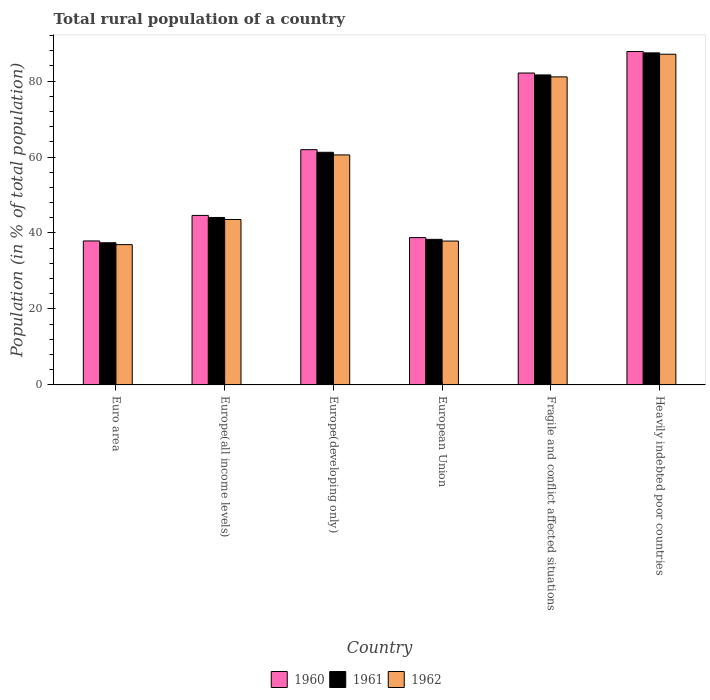How many different coloured bars are there?
Offer a very short reply. 3. Are the number of bars per tick equal to the number of legend labels?
Ensure brevity in your answer.  Yes. How many bars are there on the 2nd tick from the right?
Ensure brevity in your answer.  3. What is the label of the 6th group of bars from the left?
Offer a very short reply. Heavily indebted poor countries. In how many cases, is the number of bars for a given country not equal to the number of legend labels?
Your response must be concise. 0. What is the rural population in 1961 in Europe(developing only)?
Offer a terse response. 61.24. Across all countries, what is the maximum rural population in 1961?
Your response must be concise. 87.42. Across all countries, what is the minimum rural population in 1962?
Provide a short and direct response. 36.93. In which country was the rural population in 1961 maximum?
Make the answer very short. Heavily indebted poor countries. In which country was the rural population in 1961 minimum?
Your answer should be compact. Euro area. What is the total rural population in 1960 in the graph?
Offer a terse response. 353.12. What is the difference between the rural population in 1962 in Euro area and that in Heavily indebted poor countries?
Give a very brief answer. -50.13. What is the difference between the rural population in 1961 in European Union and the rural population in 1960 in Heavily indebted poor countries?
Ensure brevity in your answer.  -49.44. What is the average rural population in 1960 per country?
Your response must be concise. 58.85. What is the difference between the rural population of/in 1960 and rural population of/in 1961 in Euro area?
Your response must be concise. 0.48. What is the ratio of the rural population in 1961 in Fragile and conflict affected situations to that in Heavily indebted poor countries?
Make the answer very short. 0.93. Is the rural population in 1961 in Europe(all income levels) less than that in European Union?
Your response must be concise. No. Is the difference between the rural population in 1960 in Europe(all income levels) and Europe(developing only) greater than the difference between the rural population in 1961 in Europe(all income levels) and Europe(developing only)?
Offer a terse response. No. What is the difference between the highest and the second highest rural population in 1961?
Give a very brief answer. 20.37. What is the difference between the highest and the lowest rural population in 1960?
Your response must be concise. 49.86. In how many countries, is the rural population in 1962 greater than the average rural population in 1962 taken over all countries?
Keep it short and to the point. 3. Is the sum of the rural population in 1960 in Euro area and Fragile and conflict affected situations greater than the maximum rural population in 1961 across all countries?
Your answer should be very brief. Yes. What does the 3rd bar from the left in European Union represents?
Keep it short and to the point. 1962. What does the 2nd bar from the right in Heavily indebted poor countries represents?
Offer a terse response. 1961. Is it the case that in every country, the sum of the rural population in 1962 and rural population in 1961 is greater than the rural population in 1960?
Make the answer very short. Yes. How many bars are there?
Make the answer very short. 18. Are all the bars in the graph horizontal?
Your answer should be very brief. No. What is the difference between two consecutive major ticks on the Y-axis?
Offer a terse response. 20. Are the values on the major ticks of Y-axis written in scientific E-notation?
Provide a succinct answer. No. Does the graph contain any zero values?
Keep it short and to the point. No. Does the graph contain grids?
Ensure brevity in your answer.  No. What is the title of the graph?
Provide a succinct answer. Total rural population of a country. Does "1962" appear as one of the legend labels in the graph?
Provide a succinct answer. Yes. What is the label or title of the X-axis?
Your answer should be very brief. Country. What is the label or title of the Y-axis?
Your answer should be compact. Population (in % of total population). What is the Population (in % of total population) in 1960 in Euro area?
Your answer should be compact. 37.9. What is the Population (in % of total population) of 1961 in Euro area?
Your answer should be very brief. 37.42. What is the Population (in % of total population) in 1962 in Euro area?
Your response must be concise. 36.93. What is the Population (in % of total population) of 1960 in Europe(all income levels)?
Your answer should be very brief. 44.62. What is the Population (in % of total population) in 1961 in Europe(all income levels)?
Your answer should be very brief. 44.08. What is the Population (in % of total population) of 1962 in Europe(all income levels)?
Make the answer very short. 43.55. What is the Population (in % of total population) in 1960 in Europe(developing only)?
Your answer should be compact. 61.93. What is the Population (in % of total population) of 1961 in Europe(developing only)?
Provide a short and direct response. 61.24. What is the Population (in % of total population) in 1962 in Europe(developing only)?
Give a very brief answer. 60.55. What is the Population (in % of total population) of 1960 in European Union?
Ensure brevity in your answer.  38.79. What is the Population (in % of total population) in 1961 in European Union?
Make the answer very short. 38.33. What is the Population (in % of total population) of 1962 in European Union?
Make the answer very short. 37.87. What is the Population (in % of total population) in 1960 in Fragile and conflict affected situations?
Provide a succinct answer. 82.11. What is the Population (in % of total population) of 1961 in Fragile and conflict affected situations?
Your answer should be very brief. 81.61. What is the Population (in % of total population) in 1962 in Fragile and conflict affected situations?
Offer a very short reply. 81.09. What is the Population (in % of total population) in 1960 in Heavily indebted poor countries?
Provide a succinct answer. 87.76. What is the Population (in % of total population) in 1961 in Heavily indebted poor countries?
Offer a terse response. 87.42. What is the Population (in % of total population) in 1962 in Heavily indebted poor countries?
Your answer should be compact. 87.06. Across all countries, what is the maximum Population (in % of total population) in 1960?
Your answer should be compact. 87.76. Across all countries, what is the maximum Population (in % of total population) in 1961?
Provide a succinct answer. 87.42. Across all countries, what is the maximum Population (in % of total population) in 1962?
Your answer should be very brief. 87.06. Across all countries, what is the minimum Population (in % of total population) of 1960?
Provide a short and direct response. 37.9. Across all countries, what is the minimum Population (in % of total population) of 1961?
Your response must be concise. 37.42. Across all countries, what is the minimum Population (in % of total population) in 1962?
Make the answer very short. 36.93. What is the total Population (in % of total population) of 1960 in the graph?
Your response must be concise. 353.12. What is the total Population (in % of total population) of 1961 in the graph?
Your answer should be compact. 350.1. What is the total Population (in % of total population) of 1962 in the graph?
Ensure brevity in your answer.  347.05. What is the difference between the Population (in % of total population) of 1960 in Euro area and that in Europe(all income levels)?
Provide a succinct answer. -6.72. What is the difference between the Population (in % of total population) of 1961 in Euro area and that in Europe(all income levels)?
Make the answer very short. -6.66. What is the difference between the Population (in % of total population) in 1962 in Euro area and that in Europe(all income levels)?
Your answer should be compact. -6.62. What is the difference between the Population (in % of total population) of 1960 in Euro area and that in Europe(developing only)?
Provide a succinct answer. -24.03. What is the difference between the Population (in % of total population) in 1961 in Euro area and that in Europe(developing only)?
Offer a terse response. -23.82. What is the difference between the Population (in % of total population) of 1962 in Euro area and that in Europe(developing only)?
Offer a terse response. -23.62. What is the difference between the Population (in % of total population) in 1960 in Euro area and that in European Union?
Your answer should be very brief. -0.88. What is the difference between the Population (in % of total population) in 1961 in Euro area and that in European Union?
Offer a terse response. -0.9. What is the difference between the Population (in % of total population) in 1962 in Euro area and that in European Union?
Ensure brevity in your answer.  -0.94. What is the difference between the Population (in % of total population) in 1960 in Euro area and that in Fragile and conflict affected situations?
Provide a succinct answer. -44.2. What is the difference between the Population (in % of total population) of 1961 in Euro area and that in Fragile and conflict affected situations?
Keep it short and to the point. -44.19. What is the difference between the Population (in % of total population) in 1962 in Euro area and that in Fragile and conflict affected situations?
Your response must be concise. -44.16. What is the difference between the Population (in % of total population) in 1960 in Euro area and that in Heavily indebted poor countries?
Your answer should be compact. -49.86. What is the difference between the Population (in % of total population) in 1961 in Euro area and that in Heavily indebted poor countries?
Keep it short and to the point. -49.99. What is the difference between the Population (in % of total population) in 1962 in Euro area and that in Heavily indebted poor countries?
Offer a terse response. -50.13. What is the difference between the Population (in % of total population) in 1960 in Europe(all income levels) and that in Europe(developing only)?
Provide a succinct answer. -17.31. What is the difference between the Population (in % of total population) in 1961 in Europe(all income levels) and that in Europe(developing only)?
Give a very brief answer. -17.16. What is the difference between the Population (in % of total population) in 1962 in Europe(all income levels) and that in Europe(developing only)?
Your answer should be compact. -17. What is the difference between the Population (in % of total population) in 1960 in Europe(all income levels) and that in European Union?
Your response must be concise. 5.83. What is the difference between the Population (in % of total population) in 1961 in Europe(all income levels) and that in European Union?
Keep it short and to the point. 5.76. What is the difference between the Population (in % of total population) of 1962 in Europe(all income levels) and that in European Union?
Your answer should be compact. 5.68. What is the difference between the Population (in % of total population) of 1960 in Europe(all income levels) and that in Fragile and conflict affected situations?
Provide a short and direct response. -37.49. What is the difference between the Population (in % of total population) of 1961 in Europe(all income levels) and that in Fragile and conflict affected situations?
Provide a short and direct response. -37.53. What is the difference between the Population (in % of total population) in 1962 in Europe(all income levels) and that in Fragile and conflict affected situations?
Provide a short and direct response. -37.54. What is the difference between the Population (in % of total population) of 1960 in Europe(all income levels) and that in Heavily indebted poor countries?
Your answer should be compact. -43.14. What is the difference between the Population (in % of total population) of 1961 in Europe(all income levels) and that in Heavily indebted poor countries?
Your response must be concise. -43.33. What is the difference between the Population (in % of total population) in 1962 in Europe(all income levels) and that in Heavily indebted poor countries?
Offer a terse response. -43.51. What is the difference between the Population (in % of total population) of 1960 in Europe(developing only) and that in European Union?
Keep it short and to the point. 23.15. What is the difference between the Population (in % of total population) of 1961 in Europe(developing only) and that in European Union?
Provide a short and direct response. 22.91. What is the difference between the Population (in % of total population) in 1962 in Europe(developing only) and that in European Union?
Provide a short and direct response. 22.67. What is the difference between the Population (in % of total population) of 1960 in Europe(developing only) and that in Fragile and conflict affected situations?
Keep it short and to the point. -20.17. What is the difference between the Population (in % of total population) in 1961 in Europe(developing only) and that in Fragile and conflict affected situations?
Keep it short and to the point. -20.37. What is the difference between the Population (in % of total population) in 1962 in Europe(developing only) and that in Fragile and conflict affected situations?
Offer a very short reply. -20.55. What is the difference between the Population (in % of total population) in 1960 in Europe(developing only) and that in Heavily indebted poor countries?
Your answer should be very brief. -25.83. What is the difference between the Population (in % of total population) in 1961 in Europe(developing only) and that in Heavily indebted poor countries?
Provide a succinct answer. -26.18. What is the difference between the Population (in % of total population) in 1962 in Europe(developing only) and that in Heavily indebted poor countries?
Your answer should be compact. -26.51. What is the difference between the Population (in % of total population) of 1960 in European Union and that in Fragile and conflict affected situations?
Your answer should be very brief. -43.32. What is the difference between the Population (in % of total population) of 1961 in European Union and that in Fragile and conflict affected situations?
Your response must be concise. -43.28. What is the difference between the Population (in % of total population) of 1962 in European Union and that in Fragile and conflict affected situations?
Ensure brevity in your answer.  -43.22. What is the difference between the Population (in % of total population) in 1960 in European Union and that in Heavily indebted poor countries?
Offer a very short reply. -48.98. What is the difference between the Population (in % of total population) in 1961 in European Union and that in Heavily indebted poor countries?
Provide a short and direct response. -49.09. What is the difference between the Population (in % of total population) of 1962 in European Union and that in Heavily indebted poor countries?
Your response must be concise. -49.18. What is the difference between the Population (in % of total population) in 1960 in Fragile and conflict affected situations and that in Heavily indebted poor countries?
Provide a short and direct response. -5.66. What is the difference between the Population (in % of total population) in 1961 in Fragile and conflict affected situations and that in Heavily indebted poor countries?
Offer a very short reply. -5.81. What is the difference between the Population (in % of total population) of 1962 in Fragile and conflict affected situations and that in Heavily indebted poor countries?
Keep it short and to the point. -5.97. What is the difference between the Population (in % of total population) of 1960 in Euro area and the Population (in % of total population) of 1961 in Europe(all income levels)?
Keep it short and to the point. -6.18. What is the difference between the Population (in % of total population) of 1960 in Euro area and the Population (in % of total population) of 1962 in Europe(all income levels)?
Provide a short and direct response. -5.65. What is the difference between the Population (in % of total population) in 1961 in Euro area and the Population (in % of total population) in 1962 in Europe(all income levels)?
Provide a succinct answer. -6.13. What is the difference between the Population (in % of total population) in 1960 in Euro area and the Population (in % of total population) in 1961 in Europe(developing only)?
Ensure brevity in your answer.  -23.34. What is the difference between the Population (in % of total population) in 1960 in Euro area and the Population (in % of total population) in 1962 in Europe(developing only)?
Ensure brevity in your answer.  -22.64. What is the difference between the Population (in % of total population) in 1961 in Euro area and the Population (in % of total population) in 1962 in Europe(developing only)?
Provide a succinct answer. -23.12. What is the difference between the Population (in % of total population) of 1960 in Euro area and the Population (in % of total population) of 1961 in European Union?
Provide a succinct answer. -0.42. What is the difference between the Population (in % of total population) of 1960 in Euro area and the Population (in % of total population) of 1962 in European Union?
Your response must be concise. 0.03. What is the difference between the Population (in % of total population) in 1961 in Euro area and the Population (in % of total population) in 1962 in European Union?
Your answer should be very brief. -0.45. What is the difference between the Population (in % of total population) of 1960 in Euro area and the Population (in % of total population) of 1961 in Fragile and conflict affected situations?
Keep it short and to the point. -43.71. What is the difference between the Population (in % of total population) of 1960 in Euro area and the Population (in % of total population) of 1962 in Fragile and conflict affected situations?
Offer a terse response. -43.19. What is the difference between the Population (in % of total population) of 1961 in Euro area and the Population (in % of total population) of 1962 in Fragile and conflict affected situations?
Keep it short and to the point. -43.67. What is the difference between the Population (in % of total population) in 1960 in Euro area and the Population (in % of total population) in 1961 in Heavily indebted poor countries?
Ensure brevity in your answer.  -49.51. What is the difference between the Population (in % of total population) of 1960 in Euro area and the Population (in % of total population) of 1962 in Heavily indebted poor countries?
Offer a very short reply. -49.16. What is the difference between the Population (in % of total population) in 1961 in Euro area and the Population (in % of total population) in 1962 in Heavily indebted poor countries?
Ensure brevity in your answer.  -49.63. What is the difference between the Population (in % of total population) in 1960 in Europe(all income levels) and the Population (in % of total population) in 1961 in Europe(developing only)?
Keep it short and to the point. -16.62. What is the difference between the Population (in % of total population) in 1960 in Europe(all income levels) and the Population (in % of total population) in 1962 in Europe(developing only)?
Provide a short and direct response. -15.93. What is the difference between the Population (in % of total population) of 1961 in Europe(all income levels) and the Population (in % of total population) of 1962 in Europe(developing only)?
Make the answer very short. -16.46. What is the difference between the Population (in % of total population) in 1960 in Europe(all income levels) and the Population (in % of total population) in 1961 in European Union?
Give a very brief answer. 6.29. What is the difference between the Population (in % of total population) of 1960 in Europe(all income levels) and the Population (in % of total population) of 1962 in European Union?
Provide a succinct answer. 6.75. What is the difference between the Population (in % of total population) in 1961 in Europe(all income levels) and the Population (in % of total population) in 1962 in European Union?
Ensure brevity in your answer.  6.21. What is the difference between the Population (in % of total population) of 1960 in Europe(all income levels) and the Population (in % of total population) of 1961 in Fragile and conflict affected situations?
Offer a terse response. -36.99. What is the difference between the Population (in % of total population) of 1960 in Europe(all income levels) and the Population (in % of total population) of 1962 in Fragile and conflict affected situations?
Keep it short and to the point. -36.47. What is the difference between the Population (in % of total population) of 1961 in Europe(all income levels) and the Population (in % of total population) of 1962 in Fragile and conflict affected situations?
Give a very brief answer. -37.01. What is the difference between the Population (in % of total population) in 1960 in Europe(all income levels) and the Population (in % of total population) in 1961 in Heavily indebted poor countries?
Keep it short and to the point. -42.8. What is the difference between the Population (in % of total population) of 1960 in Europe(all income levels) and the Population (in % of total population) of 1962 in Heavily indebted poor countries?
Offer a very short reply. -42.44. What is the difference between the Population (in % of total population) in 1961 in Europe(all income levels) and the Population (in % of total population) in 1962 in Heavily indebted poor countries?
Your answer should be compact. -42.97. What is the difference between the Population (in % of total population) in 1960 in Europe(developing only) and the Population (in % of total population) in 1961 in European Union?
Make the answer very short. 23.61. What is the difference between the Population (in % of total population) of 1960 in Europe(developing only) and the Population (in % of total population) of 1962 in European Union?
Your answer should be compact. 24.06. What is the difference between the Population (in % of total population) in 1961 in Europe(developing only) and the Population (in % of total population) in 1962 in European Union?
Your response must be concise. 23.37. What is the difference between the Population (in % of total population) of 1960 in Europe(developing only) and the Population (in % of total population) of 1961 in Fragile and conflict affected situations?
Your answer should be very brief. -19.68. What is the difference between the Population (in % of total population) of 1960 in Europe(developing only) and the Population (in % of total population) of 1962 in Fragile and conflict affected situations?
Keep it short and to the point. -19.16. What is the difference between the Population (in % of total population) in 1961 in Europe(developing only) and the Population (in % of total population) in 1962 in Fragile and conflict affected situations?
Your answer should be very brief. -19.85. What is the difference between the Population (in % of total population) in 1960 in Europe(developing only) and the Population (in % of total population) in 1961 in Heavily indebted poor countries?
Provide a short and direct response. -25.48. What is the difference between the Population (in % of total population) in 1960 in Europe(developing only) and the Population (in % of total population) in 1962 in Heavily indebted poor countries?
Offer a very short reply. -25.12. What is the difference between the Population (in % of total population) in 1961 in Europe(developing only) and the Population (in % of total population) in 1962 in Heavily indebted poor countries?
Keep it short and to the point. -25.82. What is the difference between the Population (in % of total population) of 1960 in European Union and the Population (in % of total population) of 1961 in Fragile and conflict affected situations?
Your answer should be very brief. -42.82. What is the difference between the Population (in % of total population) in 1960 in European Union and the Population (in % of total population) in 1962 in Fragile and conflict affected situations?
Make the answer very short. -42.31. What is the difference between the Population (in % of total population) in 1961 in European Union and the Population (in % of total population) in 1962 in Fragile and conflict affected situations?
Ensure brevity in your answer.  -42.77. What is the difference between the Population (in % of total population) of 1960 in European Union and the Population (in % of total population) of 1961 in Heavily indebted poor countries?
Offer a very short reply. -48.63. What is the difference between the Population (in % of total population) in 1960 in European Union and the Population (in % of total population) in 1962 in Heavily indebted poor countries?
Your response must be concise. -48.27. What is the difference between the Population (in % of total population) of 1961 in European Union and the Population (in % of total population) of 1962 in Heavily indebted poor countries?
Offer a very short reply. -48.73. What is the difference between the Population (in % of total population) of 1960 in Fragile and conflict affected situations and the Population (in % of total population) of 1961 in Heavily indebted poor countries?
Provide a short and direct response. -5.31. What is the difference between the Population (in % of total population) in 1960 in Fragile and conflict affected situations and the Population (in % of total population) in 1962 in Heavily indebted poor countries?
Keep it short and to the point. -4.95. What is the difference between the Population (in % of total population) of 1961 in Fragile and conflict affected situations and the Population (in % of total population) of 1962 in Heavily indebted poor countries?
Provide a short and direct response. -5.45. What is the average Population (in % of total population) of 1960 per country?
Your answer should be very brief. 58.85. What is the average Population (in % of total population) in 1961 per country?
Your answer should be very brief. 58.35. What is the average Population (in % of total population) of 1962 per country?
Ensure brevity in your answer.  57.84. What is the difference between the Population (in % of total population) in 1960 and Population (in % of total population) in 1961 in Euro area?
Make the answer very short. 0.48. What is the difference between the Population (in % of total population) in 1960 and Population (in % of total population) in 1962 in Euro area?
Make the answer very short. 0.97. What is the difference between the Population (in % of total population) in 1961 and Population (in % of total population) in 1962 in Euro area?
Provide a succinct answer. 0.49. What is the difference between the Population (in % of total population) in 1960 and Population (in % of total population) in 1961 in Europe(all income levels)?
Keep it short and to the point. 0.54. What is the difference between the Population (in % of total population) of 1960 and Population (in % of total population) of 1962 in Europe(all income levels)?
Your response must be concise. 1.07. What is the difference between the Population (in % of total population) in 1961 and Population (in % of total population) in 1962 in Europe(all income levels)?
Keep it short and to the point. 0.53. What is the difference between the Population (in % of total population) of 1960 and Population (in % of total population) of 1961 in Europe(developing only)?
Keep it short and to the point. 0.69. What is the difference between the Population (in % of total population) of 1960 and Population (in % of total population) of 1962 in Europe(developing only)?
Keep it short and to the point. 1.39. What is the difference between the Population (in % of total population) of 1961 and Population (in % of total population) of 1962 in Europe(developing only)?
Your response must be concise. 0.69. What is the difference between the Population (in % of total population) of 1960 and Population (in % of total population) of 1961 in European Union?
Make the answer very short. 0.46. What is the difference between the Population (in % of total population) in 1960 and Population (in % of total population) in 1962 in European Union?
Offer a terse response. 0.91. What is the difference between the Population (in % of total population) in 1961 and Population (in % of total population) in 1962 in European Union?
Keep it short and to the point. 0.45. What is the difference between the Population (in % of total population) in 1960 and Population (in % of total population) in 1961 in Fragile and conflict affected situations?
Offer a terse response. 0.5. What is the difference between the Population (in % of total population) in 1960 and Population (in % of total population) in 1962 in Fragile and conflict affected situations?
Provide a short and direct response. 1.02. What is the difference between the Population (in % of total population) in 1961 and Population (in % of total population) in 1962 in Fragile and conflict affected situations?
Your response must be concise. 0.52. What is the difference between the Population (in % of total population) in 1960 and Population (in % of total population) in 1961 in Heavily indebted poor countries?
Make the answer very short. 0.35. What is the difference between the Population (in % of total population) in 1960 and Population (in % of total population) in 1962 in Heavily indebted poor countries?
Keep it short and to the point. 0.71. What is the difference between the Population (in % of total population) of 1961 and Population (in % of total population) of 1962 in Heavily indebted poor countries?
Your response must be concise. 0.36. What is the ratio of the Population (in % of total population) in 1960 in Euro area to that in Europe(all income levels)?
Keep it short and to the point. 0.85. What is the ratio of the Population (in % of total population) of 1961 in Euro area to that in Europe(all income levels)?
Offer a terse response. 0.85. What is the ratio of the Population (in % of total population) of 1962 in Euro area to that in Europe(all income levels)?
Provide a short and direct response. 0.85. What is the ratio of the Population (in % of total population) of 1960 in Euro area to that in Europe(developing only)?
Provide a short and direct response. 0.61. What is the ratio of the Population (in % of total population) of 1961 in Euro area to that in Europe(developing only)?
Make the answer very short. 0.61. What is the ratio of the Population (in % of total population) in 1962 in Euro area to that in Europe(developing only)?
Make the answer very short. 0.61. What is the ratio of the Population (in % of total population) of 1960 in Euro area to that in European Union?
Offer a terse response. 0.98. What is the ratio of the Population (in % of total population) of 1961 in Euro area to that in European Union?
Give a very brief answer. 0.98. What is the ratio of the Population (in % of total population) of 1962 in Euro area to that in European Union?
Give a very brief answer. 0.98. What is the ratio of the Population (in % of total population) of 1960 in Euro area to that in Fragile and conflict affected situations?
Offer a very short reply. 0.46. What is the ratio of the Population (in % of total population) in 1961 in Euro area to that in Fragile and conflict affected situations?
Provide a short and direct response. 0.46. What is the ratio of the Population (in % of total population) of 1962 in Euro area to that in Fragile and conflict affected situations?
Provide a succinct answer. 0.46. What is the ratio of the Population (in % of total population) in 1960 in Euro area to that in Heavily indebted poor countries?
Provide a succinct answer. 0.43. What is the ratio of the Population (in % of total population) of 1961 in Euro area to that in Heavily indebted poor countries?
Provide a short and direct response. 0.43. What is the ratio of the Population (in % of total population) of 1962 in Euro area to that in Heavily indebted poor countries?
Your answer should be compact. 0.42. What is the ratio of the Population (in % of total population) of 1960 in Europe(all income levels) to that in Europe(developing only)?
Provide a succinct answer. 0.72. What is the ratio of the Population (in % of total population) in 1961 in Europe(all income levels) to that in Europe(developing only)?
Your answer should be compact. 0.72. What is the ratio of the Population (in % of total population) in 1962 in Europe(all income levels) to that in Europe(developing only)?
Make the answer very short. 0.72. What is the ratio of the Population (in % of total population) in 1960 in Europe(all income levels) to that in European Union?
Your answer should be very brief. 1.15. What is the ratio of the Population (in % of total population) in 1961 in Europe(all income levels) to that in European Union?
Give a very brief answer. 1.15. What is the ratio of the Population (in % of total population) of 1962 in Europe(all income levels) to that in European Union?
Offer a very short reply. 1.15. What is the ratio of the Population (in % of total population) of 1960 in Europe(all income levels) to that in Fragile and conflict affected situations?
Keep it short and to the point. 0.54. What is the ratio of the Population (in % of total population) in 1961 in Europe(all income levels) to that in Fragile and conflict affected situations?
Keep it short and to the point. 0.54. What is the ratio of the Population (in % of total population) of 1962 in Europe(all income levels) to that in Fragile and conflict affected situations?
Offer a terse response. 0.54. What is the ratio of the Population (in % of total population) in 1960 in Europe(all income levels) to that in Heavily indebted poor countries?
Ensure brevity in your answer.  0.51. What is the ratio of the Population (in % of total population) of 1961 in Europe(all income levels) to that in Heavily indebted poor countries?
Make the answer very short. 0.5. What is the ratio of the Population (in % of total population) of 1962 in Europe(all income levels) to that in Heavily indebted poor countries?
Make the answer very short. 0.5. What is the ratio of the Population (in % of total population) in 1960 in Europe(developing only) to that in European Union?
Offer a very short reply. 1.6. What is the ratio of the Population (in % of total population) of 1961 in Europe(developing only) to that in European Union?
Offer a terse response. 1.6. What is the ratio of the Population (in % of total population) of 1962 in Europe(developing only) to that in European Union?
Offer a terse response. 1.6. What is the ratio of the Population (in % of total population) of 1960 in Europe(developing only) to that in Fragile and conflict affected situations?
Offer a very short reply. 0.75. What is the ratio of the Population (in % of total population) of 1961 in Europe(developing only) to that in Fragile and conflict affected situations?
Make the answer very short. 0.75. What is the ratio of the Population (in % of total population) of 1962 in Europe(developing only) to that in Fragile and conflict affected situations?
Provide a short and direct response. 0.75. What is the ratio of the Population (in % of total population) in 1960 in Europe(developing only) to that in Heavily indebted poor countries?
Ensure brevity in your answer.  0.71. What is the ratio of the Population (in % of total population) in 1961 in Europe(developing only) to that in Heavily indebted poor countries?
Offer a very short reply. 0.7. What is the ratio of the Population (in % of total population) of 1962 in Europe(developing only) to that in Heavily indebted poor countries?
Make the answer very short. 0.7. What is the ratio of the Population (in % of total population) in 1960 in European Union to that in Fragile and conflict affected situations?
Offer a very short reply. 0.47. What is the ratio of the Population (in % of total population) of 1961 in European Union to that in Fragile and conflict affected situations?
Make the answer very short. 0.47. What is the ratio of the Population (in % of total population) in 1962 in European Union to that in Fragile and conflict affected situations?
Your response must be concise. 0.47. What is the ratio of the Population (in % of total population) of 1960 in European Union to that in Heavily indebted poor countries?
Keep it short and to the point. 0.44. What is the ratio of the Population (in % of total population) of 1961 in European Union to that in Heavily indebted poor countries?
Offer a terse response. 0.44. What is the ratio of the Population (in % of total population) in 1962 in European Union to that in Heavily indebted poor countries?
Your answer should be compact. 0.43. What is the ratio of the Population (in % of total population) in 1960 in Fragile and conflict affected situations to that in Heavily indebted poor countries?
Your answer should be very brief. 0.94. What is the ratio of the Population (in % of total population) of 1961 in Fragile and conflict affected situations to that in Heavily indebted poor countries?
Your answer should be very brief. 0.93. What is the ratio of the Population (in % of total population) of 1962 in Fragile and conflict affected situations to that in Heavily indebted poor countries?
Provide a short and direct response. 0.93. What is the difference between the highest and the second highest Population (in % of total population) in 1960?
Provide a short and direct response. 5.66. What is the difference between the highest and the second highest Population (in % of total population) in 1961?
Keep it short and to the point. 5.81. What is the difference between the highest and the second highest Population (in % of total population) in 1962?
Make the answer very short. 5.97. What is the difference between the highest and the lowest Population (in % of total population) in 1960?
Ensure brevity in your answer.  49.86. What is the difference between the highest and the lowest Population (in % of total population) of 1961?
Your response must be concise. 49.99. What is the difference between the highest and the lowest Population (in % of total population) in 1962?
Your answer should be very brief. 50.13. 